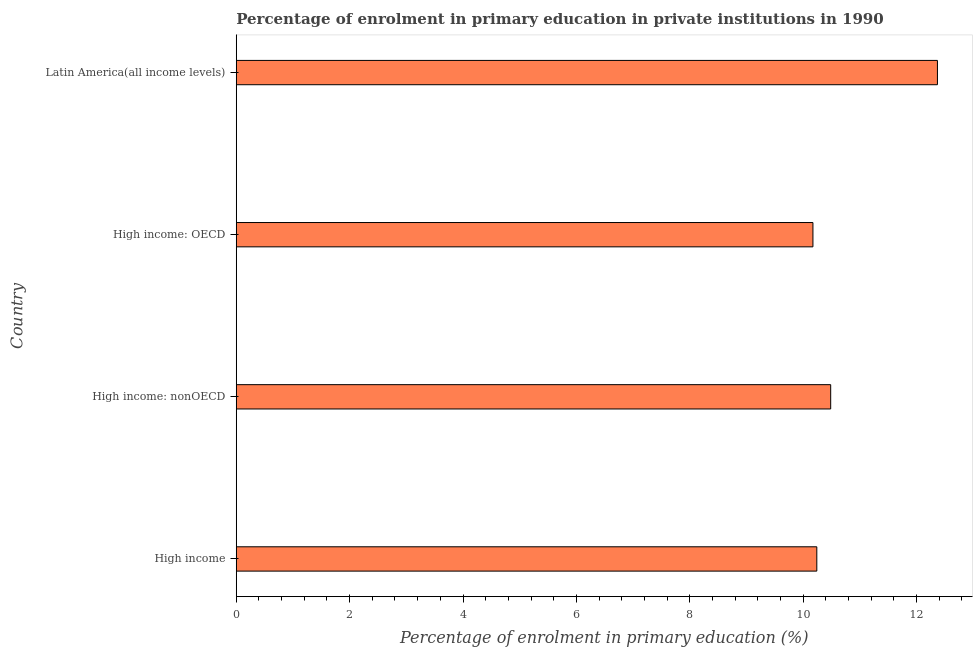Does the graph contain any zero values?
Your answer should be very brief. No. Does the graph contain grids?
Provide a short and direct response. No. What is the title of the graph?
Keep it short and to the point. Percentage of enrolment in primary education in private institutions in 1990. What is the label or title of the X-axis?
Your answer should be compact. Percentage of enrolment in primary education (%). What is the enrolment percentage in primary education in High income: nonOECD?
Provide a succinct answer. 10.49. Across all countries, what is the maximum enrolment percentage in primary education?
Your answer should be very brief. 12.37. Across all countries, what is the minimum enrolment percentage in primary education?
Provide a short and direct response. 10.17. In which country was the enrolment percentage in primary education maximum?
Ensure brevity in your answer.  Latin America(all income levels). In which country was the enrolment percentage in primary education minimum?
Offer a very short reply. High income: OECD. What is the sum of the enrolment percentage in primary education?
Your answer should be compact. 43.27. What is the difference between the enrolment percentage in primary education in High income and Latin America(all income levels)?
Give a very brief answer. -2.13. What is the average enrolment percentage in primary education per country?
Your answer should be compact. 10.82. What is the median enrolment percentage in primary education?
Offer a very short reply. 10.36. In how many countries, is the enrolment percentage in primary education greater than 10.4 %?
Keep it short and to the point. 2. What is the ratio of the enrolment percentage in primary education in High income: OECD to that in High income: nonOECD?
Provide a short and direct response. 0.97. Is the difference between the enrolment percentage in primary education in High income and High income: OECD greater than the difference between any two countries?
Provide a succinct answer. No. What is the difference between the highest and the second highest enrolment percentage in primary education?
Offer a terse response. 1.88. In how many countries, is the enrolment percentage in primary education greater than the average enrolment percentage in primary education taken over all countries?
Provide a succinct answer. 1. How many countries are there in the graph?
Offer a terse response. 4. What is the difference between two consecutive major ticks on the X-axis?
Keep it short and to the point. 2. What is the Percentage of enrolment in primary education (%) in High income?
Provide a succinct answer. 10.24. What is the Percentage of enrolment in primary education (%) in High income: nonOECD?
Provide a succinct answer. 10.49. What is the Percentage of enrolment in primary education (%) in High income: OECD?
Your answer should be compact. 10.17. What is the Percentage of enrolment in primary education (%) in Latin America(all income levels)?
Your answer should be compact. 12.37. What is the difference between the Percentage of enrolment in primary education (%) in High income and High income: nonOECD?
Keep it short and to the point. -0.24. What is the difference between the Percentage of enrolment in primary education (%) in High income and High income: OECD?
Provide a short and direct response. 0.07. What is the difference between the Percentage of enrolment in primary education (%) in High income and Latin America(all income levels)?
Your answer should be compact. -2.13. What is the difference between the Percentage of enrolment in primary education (%) in High income: nonOECD and High income: OECD?
Give a very brief answer. 0.31. What is the difference between the Percentage of enrolment in primary education (%) in High income: nonOECD and Latin America(all income levels)?
Your answer should be compact. -1.88. What is the difference between the Percentage of enrolment in primary education (%) in High income: OECD and Latin America(all income levels)?
Provide a short and direct response. -2.2. What is the ratio of the Percentage of enrolment in primary education (%) in High income to that in High income: nonOECD?
Ensure brevity in your answer.  0.98. What is the ratio of the Percentage of enrolment in primary education (%) in High income to that in High income: OECD?
Provide a succinct answer. 1.01. What is the ratio of the Percentage of enrolment in primary education (%) in High income to that in Latin America(all income levels)?
Your answer should be compact. 0.83. What is the ratio of the Percentage of enrolment in primary education (%) in High income: nonOECD to that in High income: OECD?
Your answer should be compact. 1.03. What is the ratio of the Percentage of enrolment in primary education (%) in High income: nonOECD to that in Latin America(all income levels)?
Your answer should be very brief. 0.85. What is the ratio of the Percentage of enrolment in primary education (%) in High income: OECD to that in Latin America(all income levels)?
Offer a very short reply. 0.82. 